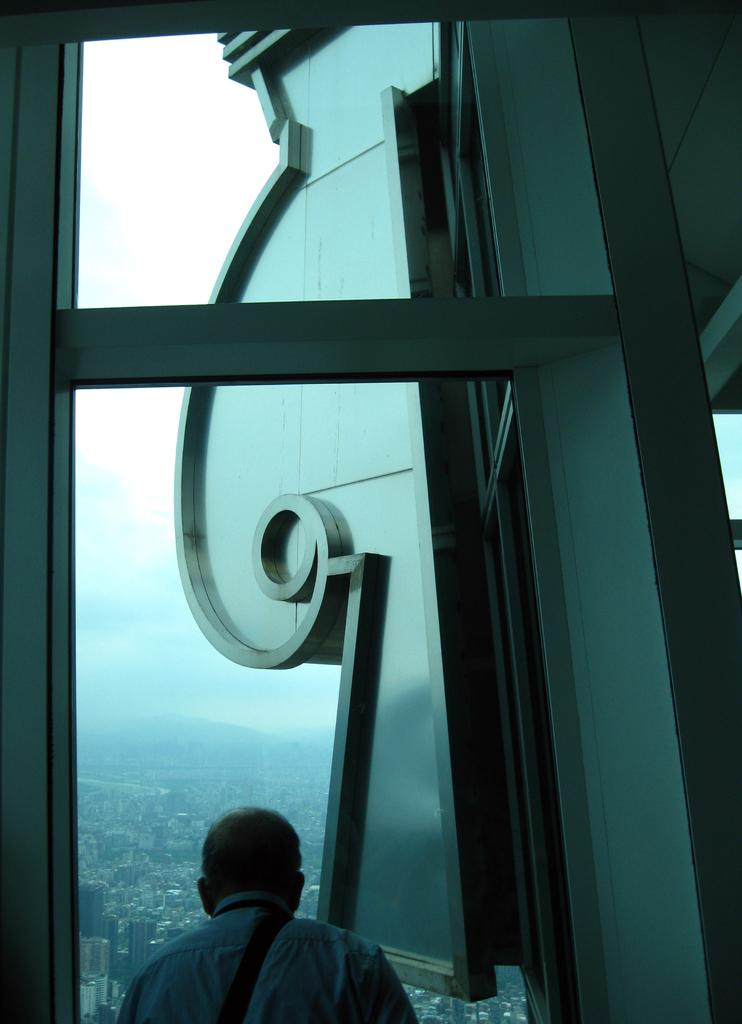Who or what is present in the image? There is a person in the image. What can be seen in the background of the image? There is a window in the image, and buildings and hills are visible from the window. What is visible at the top of the image? The sky is visible at the top of the image. What type of cherry is being used as a decoration in the image? There is no cherry present in the image. How does the string help the person in the image? There is no string mentioned in the image, so it cannot be determined how it might help the person. 